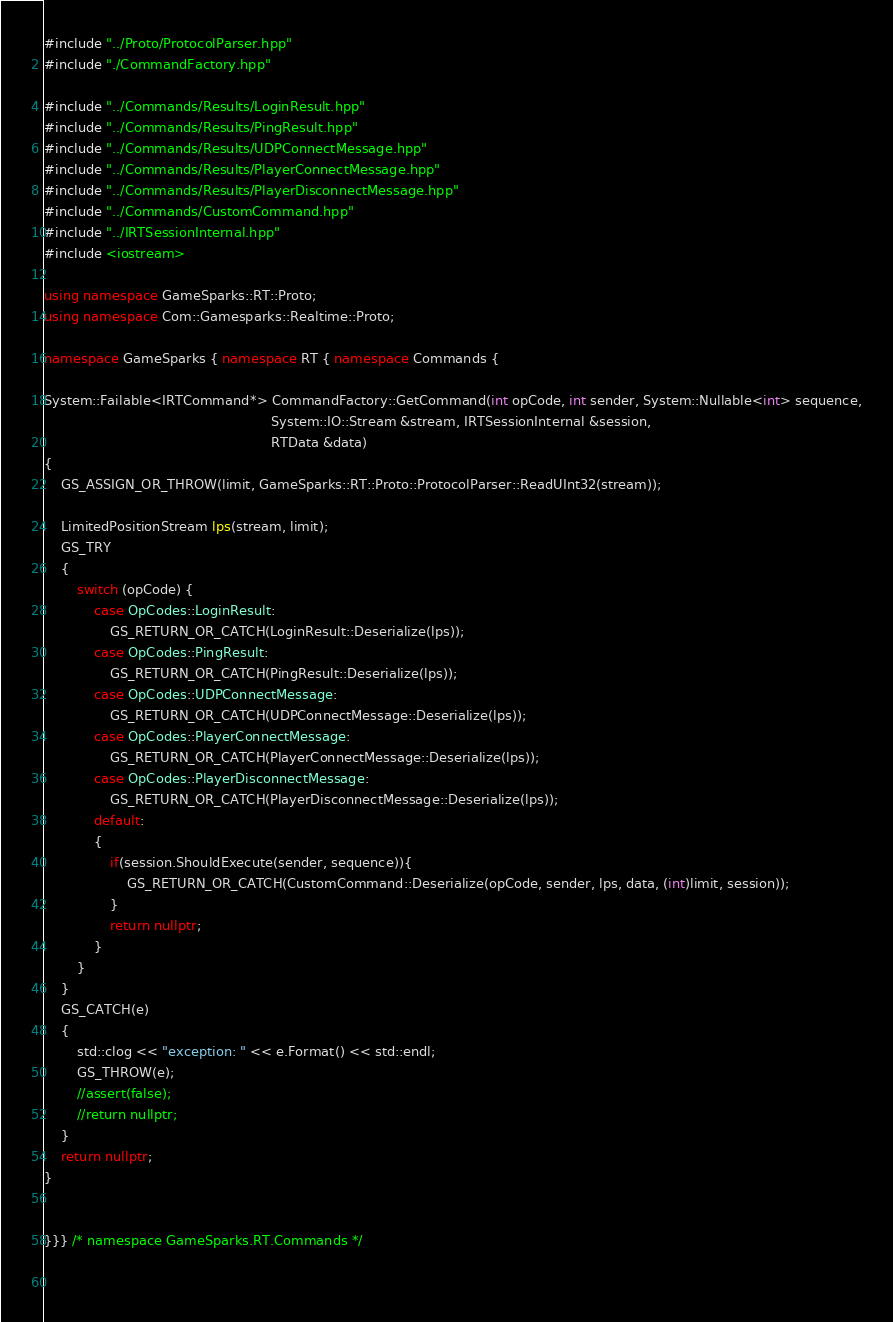Convert code to text. <code><loc_0><loc_0><loc_500><loc_500><_C++_>#include "../Proto/ProtocolParser.hpp"
#include "./CommandFactory.hpp"

#include "../Commands/Results/LoginResult.hpp"
#include "../Commands/Results/PingResult.hpp"
#include "../Commands/Results/UDPConnectMessage.hpp"
#include "../Commands/Results/PlayerConnectMessage.hpp"
#include "../Commands/Results/PlayerDisconnectMessage.hpp"
#include "../Commands/CustomCommand.hpp"
#include "../IRTSessionInternal.hpp"
#include <iostream>

using namespace GameSparks::RT::Proto;
using namespace Com::Gamesparks::Realtime::Proto;

namespace GameSparks { namespace RT { namespace Commands {

System::Failable<IRTCommand*> CommandFactory::GetCommand(int opCode, int sender, System::Nullable<int> sequence,
                                                       System::IO::Stream &stream, IRTSessionInternal &session,
                                                       RTData &data)
{
    GS_ASSIGN_OR_THROW(limit, GameSparks::RT::Proto::ProtocolParser::ReadUInt32(stream));

    LimitedPositionStream lps(stream, limit);
    GS_TRY
    {
        switch (opCode) {
            case OpCodes::LoginResult:
                GS_RETURN_OR_CATCH(LoginResult::Deserialize(lps));
            case OpCodes::PingResult:
                GS_RETURN_OR_CATCH(PingResult::Deserialize(lps));
            case OpCodes::UDPConnectMessage:
                GS_RETURN_OR_CATCH(UDPConnectMessage::Deserialize(lps));
            case OpCodes::PlayerConnectMessage:
                GS_RETURN_OR_CATCH(PlayerConnectMessage::Deserialize(lps));
            case OpCodes::PlayerDisconnectMessage:
                GS_RETURN_OR_CATCH(PlayerDisconnectMessage::Deserialize(lps));
            default:
            {
                if(session.ShouldExecute(sender, sequence)){
                    GS_RETURN_OR_CATCH(CustomCommand::Deserialize(opCode, sender, lps, data, (int)limit, session));
                }
                return nullptr;
            }
        }
    }
    GS_CATCH(e)
    {
        std::clog << "exception: " << e.Format() << std::endl;
        GS_THROW(e);
        //assert(false);
		//return nullptr;
    }
    return nullptr;
}


}}} /* namespace GameSparks.RT.Commands */

	</code> 